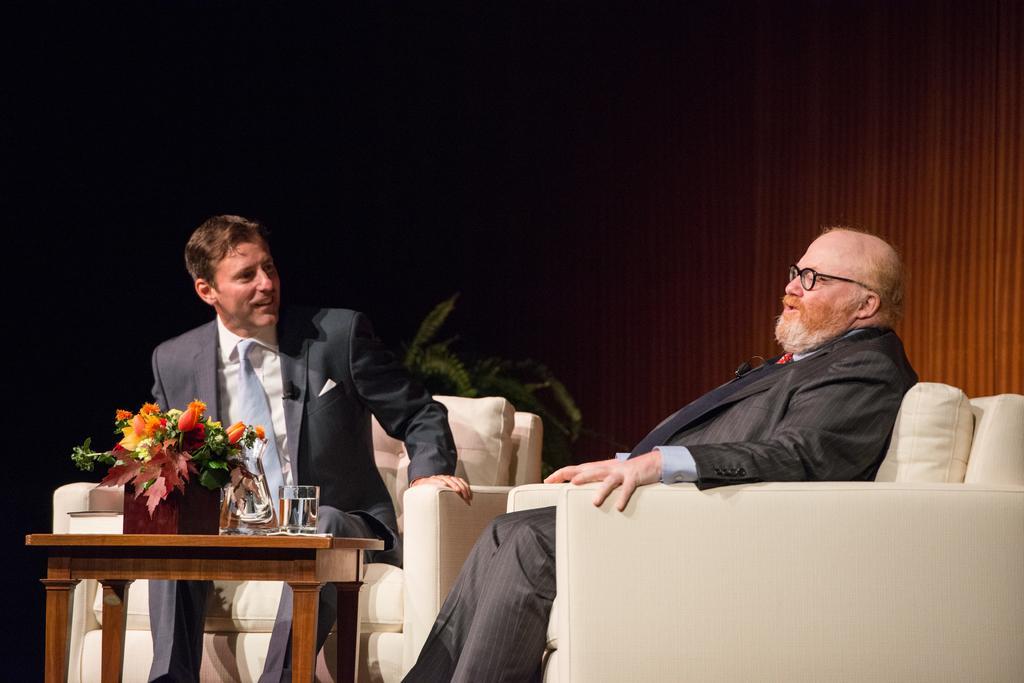In one or two sentences, can you explain what this image depicts? In this image I can see a two person sitting on the couch. On the table there is flower pot and a glass. 